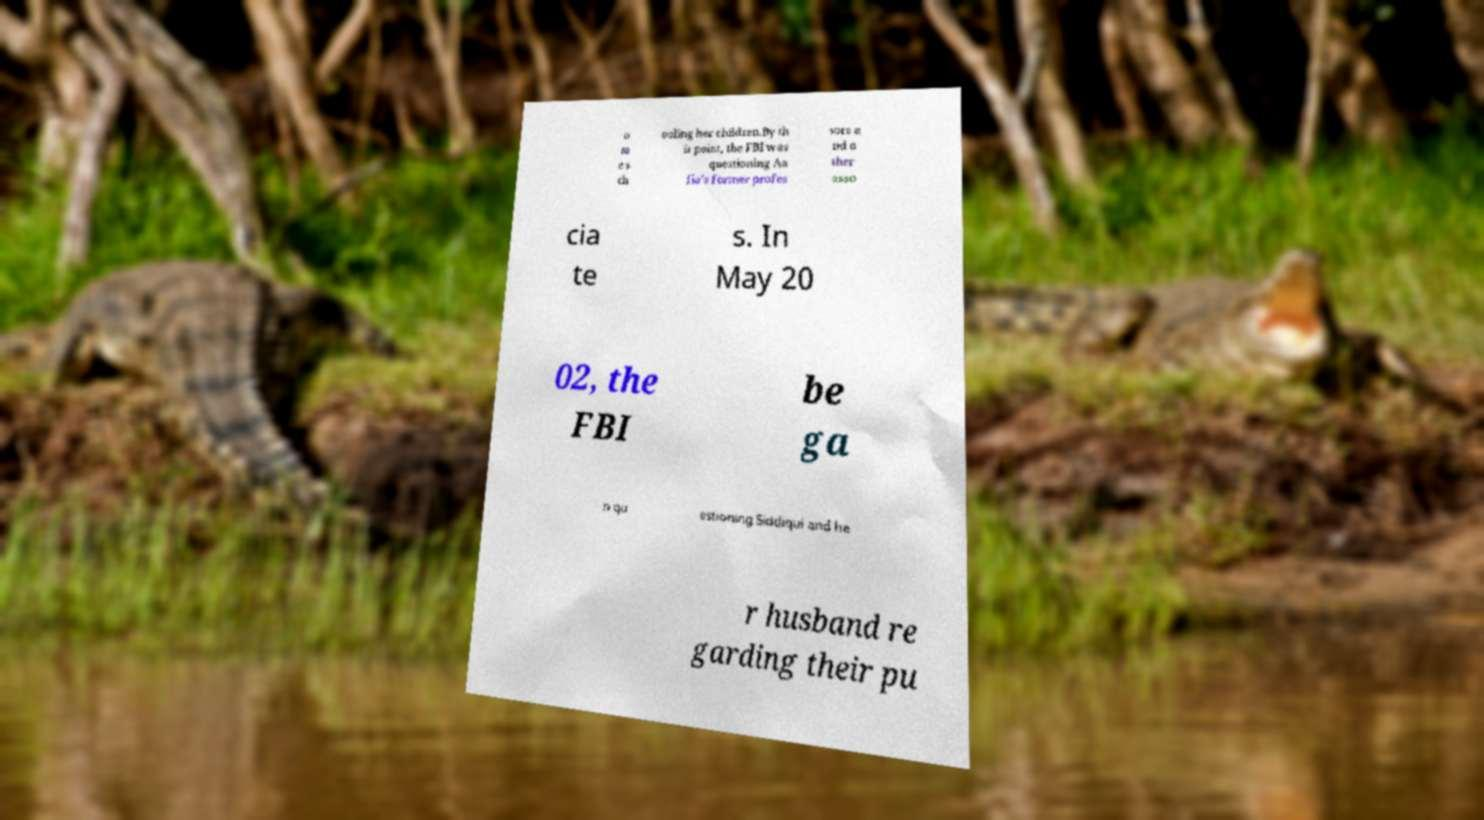There's text embedded in this image that I need extracted. Can you transcribe it verbatim? o m e s ch ooling her children.By th is point, the FBI was questioning Aa fia's former profes sors a nd o ther asso cia te s. In May 20 02, the FBI be ga n qu estioning Siddiqui and he r husband re garding their pu 